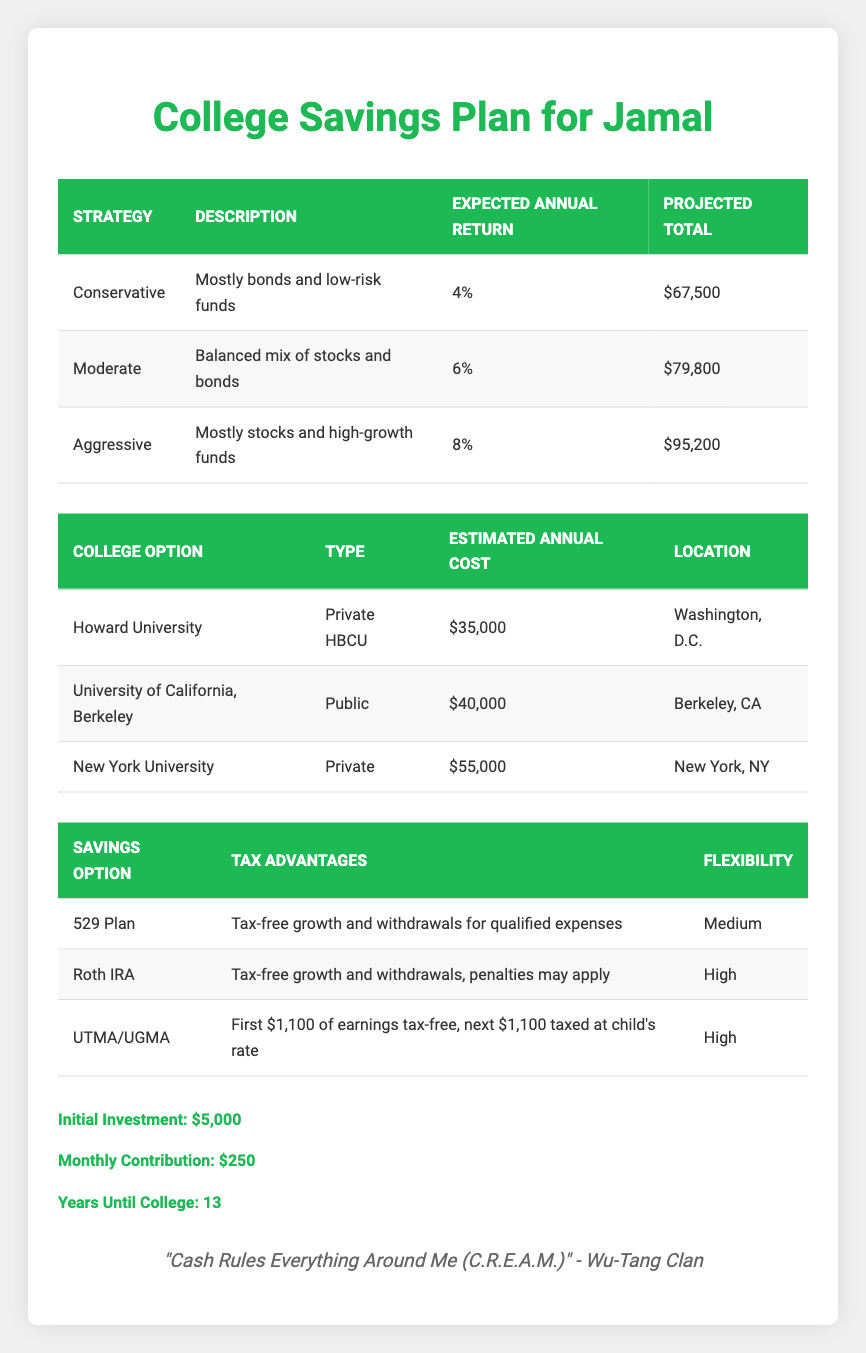What is the projected total savings using the Conservative investment strategy? The projected total for the Conservative investment strategy listed in the table is $67,500.
Answer: $67,500 What is the estimated annual cost of New York University? According to the table, the estimated annual cost for New York University is $55,000.
Answer: $55,000 Which investment strategy has the highest expected annual return? The investment strategy that has the highest expected annual return is the Aggressive strategy with an expected annual return of 8%.
Answer: Aggressive strategy What is the total cost for four years at Howard University? The estimated annual cost of attending Howard University is $35,000. To find the total for four years, multiply $35,000 by 4, resulting in a total of $140,000.
Answer: $140,000 Which savings option provides tax-free growth and withdrawals for qualified expenses? The 529 Plan provides tax-free growth and withdrawals for qualified expenses, as stated in the table.
Answer: 529 Plan Is the estimated annual cost for the University of California, Berkeley higher than $38,000? The estimated annual cost for the University of California, Berkeley is $40,000, which is indeed higher than $38,000.
Answer: Yes What is the range of expected annual returns among the investment strategies? The expected annual returns for Conservative, Moderate, and Aggressive strategies are 4%, 6%, and 8%, respectively. So the range is calculated as 8% - 4% = 4%.
Answer: 4% Would you have enough savings for New York University if you choose the Conservative investment strategy? The projected total savings using the Conservative investment strategy is $67,500, while the cost for four years at New York University is $220,000 ($55,000 x 4). Comparing these, $67,500 is not enough to cover the total cost.
Answer: No What is the average estimated annual cost of the colleges listed in the table? The estimated annual costs for the three colleges are $35,000 (Howard University), $40,000 (UCB), and $55,000 (NYU). To find the average: (35,000 + 40,000 + 55,000) / 3 = $43,333.33.
Answer: $43,333.33 